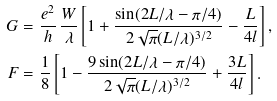<formula> <loc_0><loc_0><loc_500><loc_500>G & = \frac { e ^ { 2 } } { h } \, \frac { W } { \lambda } \left [ 1 + \frac { \sin ( 2 L / \lambda - \pi / 4 ) } { 2 \sqrt { \pi } ( L / \lambda ) ^ { 3 / 2 } } - \frac { L } { 4 l } \right ] , \\ F & = \frac { 1 } { 8 } \left [ 1 - \frac { 9 \sin ( 2 L / \lambda - \pi / 4 ) } { 2 \sqrt { \pi } ( L / \lambda ) ^ { 3 / 2 } } + \frac { 3 L } { 4 l } \right ] .</formula> 